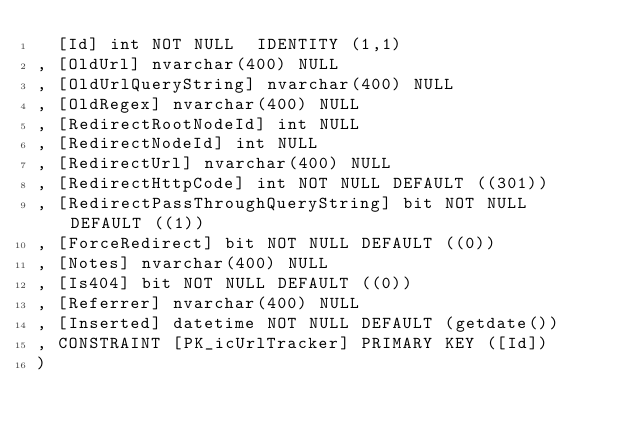Convert code to text. <code><loc_0><loc_0><loc_500><loc_500><_SQL_>  [Id] int NOT NULL  IDENTITY (1,1)
, [OldUrl] nvarchar(400) NULL
, [OldUrlQueryString] nvarchar(400) NULL
, [OldRegex] nvarchar(400) NULL
, [RedirectRootNodeId] int NULL
, [RedirectNodeId] int NULL
, [RedirectUrl] nvarchar(400) NULL
, [RedirectHttpCode] int NOT NULL DEFAULT ((301))
, [RedirectPassThroughQueryString] bit NOT NULL DEFAULT ((1))
, [ForceRedirect] bit NOT NULL DEFAULT ((0))
, [Notes] nvarchar(400) NULL
, [Is404] bit NOT NULL DEFAULT ((0))
, [Referrer] nvarchar(400) NULL
, [Inserted] datetime NOT NULL DEFAULT (getdate())
, CONSTRAINT [PK_icUrlTracker] PRIMARY KEY ([Id])
)</code> 